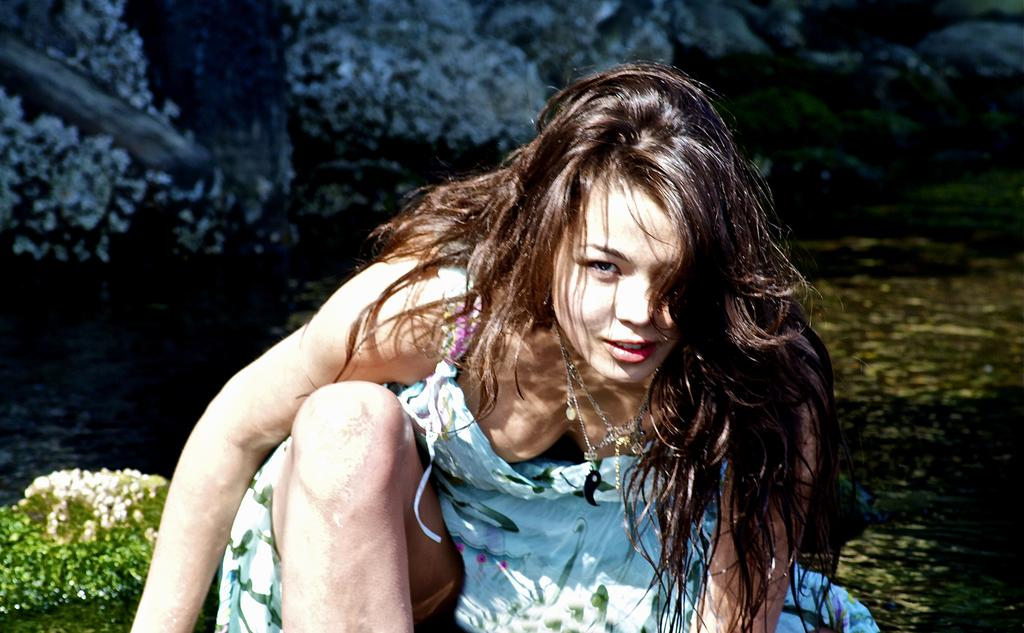Who is the main subject in the image? There is a woman in the image. What position is the woman in? The woman is sitting in a squat position. What is the woman wearing? The woman is wearing a dress and a necklace. What can be seen in the background of the image? There are trees in the background of the image. What is happening in the foreground of the image? There appears to be water flowing in the image. How does the loaf of bread interact with the woman in the image? There is no loaf of bread present in the image. What does the stranger say to the woman in the image? There is no stranger present in the image, so it is not possible to determine what they might say. 